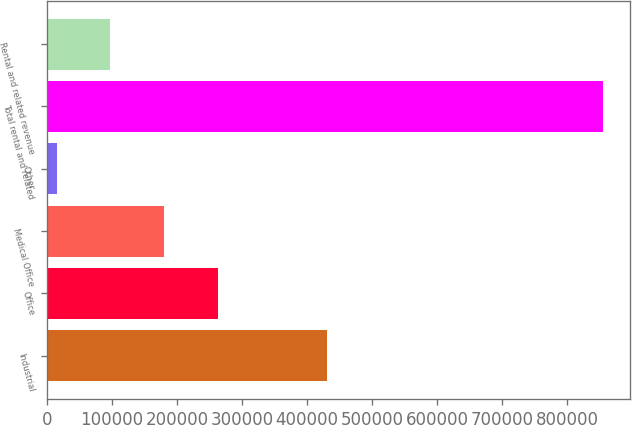Convert chart. <chart><loc_0><loc_0><loc_500><loc_500><bar_chart><fcel>Industrial<fcel>Office<fcel>Medical Office<fcel>Other<fcel>Total rental and related<fcel>Rental and related revenue<nl><fcel>431277<fcel>263063<fcel>180264<fcel>14667<fcel>854424<fcel>97465.6<nl></chart> 